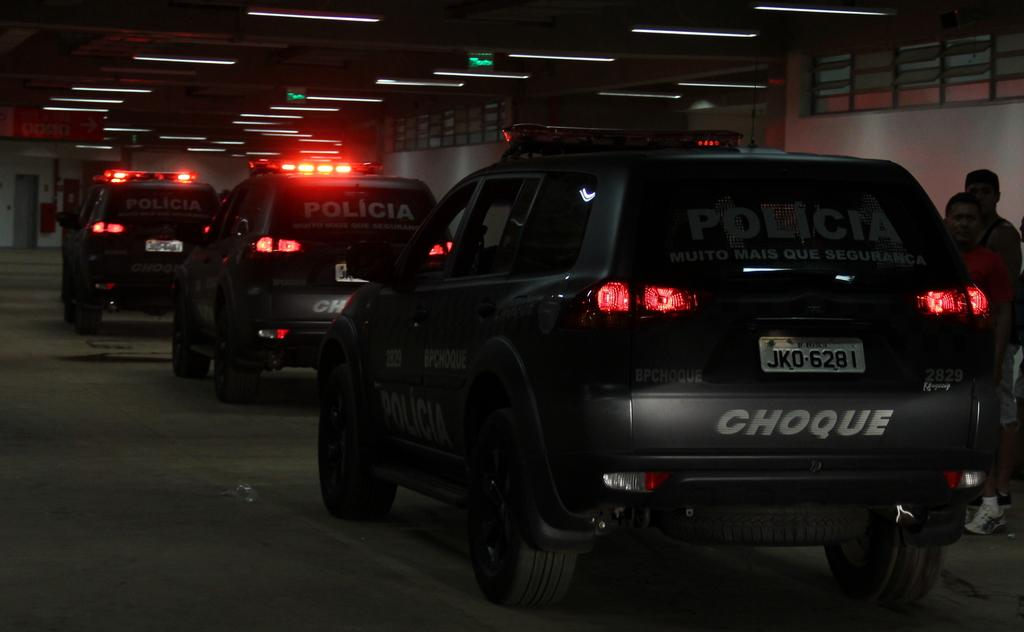<image>
Give a short and clear explanation of the subsequent image. Several black police vehicles drive through a tunnel with Choque written on their back bumper. 